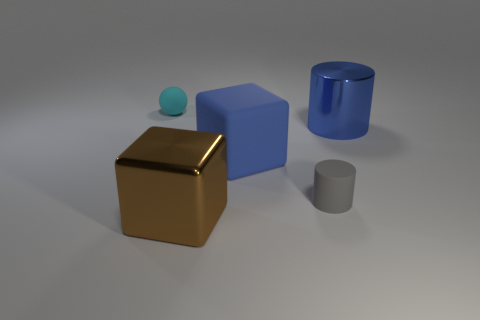Add 4 rubber balls. How many objects exist? 9 Subtract all gray cylinders. How many cylinders are left? 1 Subtract all cubes. How many objects are left? 3 Subtract 2 cubes. How many cubes are left? 0 Subtract all large things. Subtract all big red shiny cylinders. How many objects are left? 2 Add 4 blue objects. How many blue objects are left? 6 Add 1 brown metal objects. How many brown metal objects exist? 2 Subtract 0 purple blocks. How many objects are left? 5 Subtract all red cylinders. Subtract all cyan cubes. How many cylinders are left? 2 Subtract all yellow balls. How many gray cylinders are left? 1 